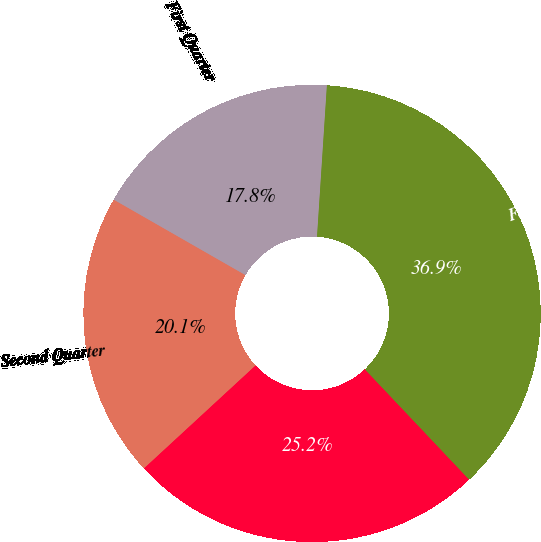Convert chart. <chart><loc_0><loc_0><loc_500><loc_500><pie_chart><fcel>First Quarter<fcel>Second Quarter<fcel>Third Quarter<fcel>Fourth Quarter<nl><fcel>17.76%<fcel>20.14%<fcel>25.2%<fcel>36.91%<nl></chart> 